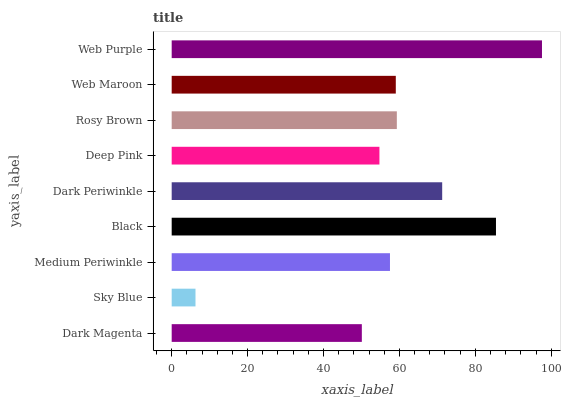Is Sky Blue the minimum?
Answer yes or no. Yes. Is Web Purple the maximum?
Answer yes or no. Yes. Is Medium Periwinkle the minimum?
Answer yes or no. No. Is Medium Periwinkle the maximum?
Answer yes or no. No. Is Medium Periwinkle greater than Sky Blue?
Answer yes or no. Yes. Is Sky Blue less than Medium Periwinkle?
Answer yes or no. Yes. Is Sky Blue greater than Medium Periwinkle?
Answer yes or no. No. Is Medium Periwinkle less than Sky Blue?
Answer yes or no. No. Is Web Maroon the high median?
Answer yes or no. Yes. Is Web Maroon the low median?
Answer yes or no. Yes. Is Dark Periwinkle the high median?
Answer yes or no. No. Is Deep Pink the low median?
Answer yes or no. No. 